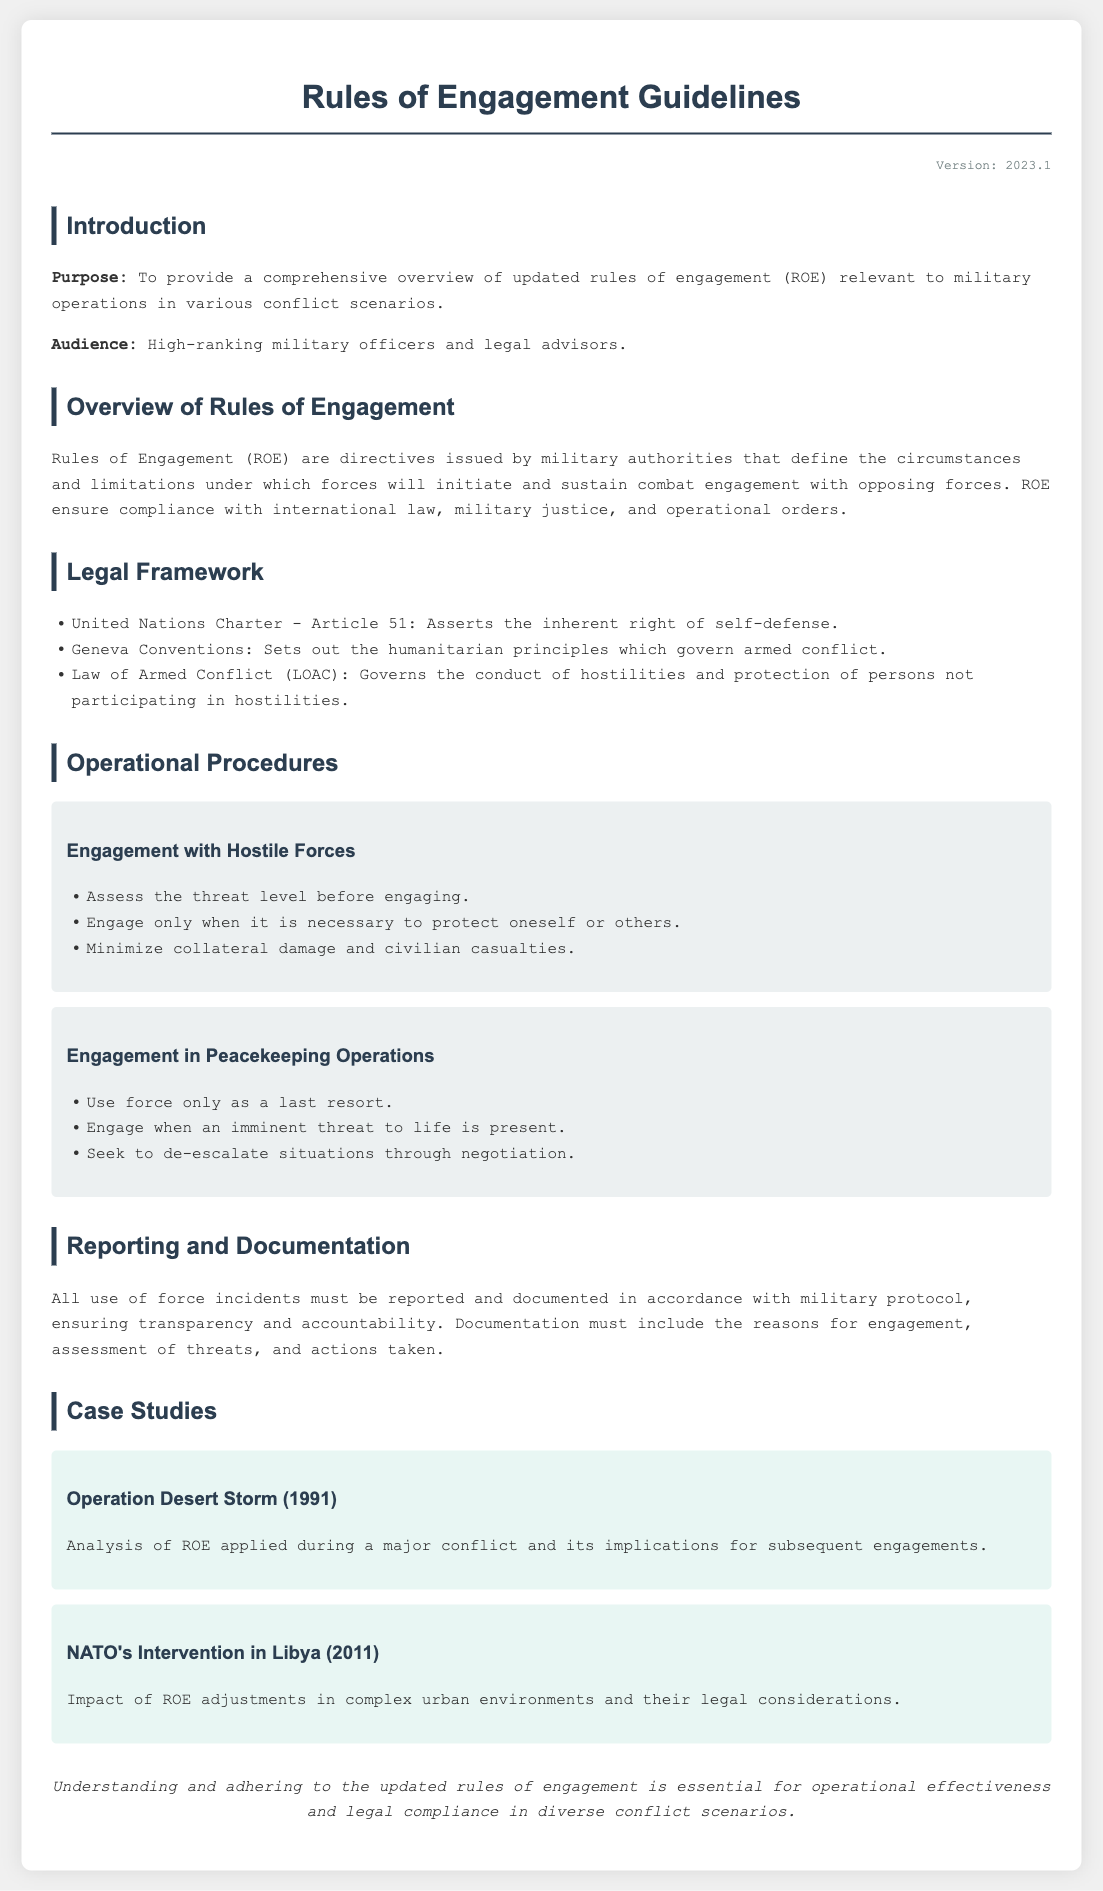What is the version of the document? The version of the document is stated in the header section, indicating its most recent update.
Answer: 2023.1 What is the purpose of the document? The purpose is outlined in the introduction, providing a clear statement about its intentions.
Answer: To provide a comprehensive overview of updated rules of engagement What article of the United Nations Charter is mentioned? The specific article is listed under the legal framework section of the document.
Answer: Article 51 What should be done before engaging with hostile forces? The operational procedure specifies an important action to take prior to engagement with opposing forces.
Answer: Assess the threat level What must be included in the documentation of use of force incidents? Documentation requirements are detailed in the reporting section, focusing on necessary elements.
Answer: The reasons for engagement What is emphasized regarding engagements in peacekeeping operations? The guidelines highlight a crucial principle that should govern the use of force in peacekeeping situations.
Answer: Use force only as a last resort What case study is related to NATO's intervention? The case studies section discusses specific military operations and their implications for ROE.
Answer: NATO's Intervention in Libya (2011) What does LOAC stand for? This abbreviation is mentioned in the legal framework, pertaining to a significant set of laws.
Answer: Law of Armed Conflict 